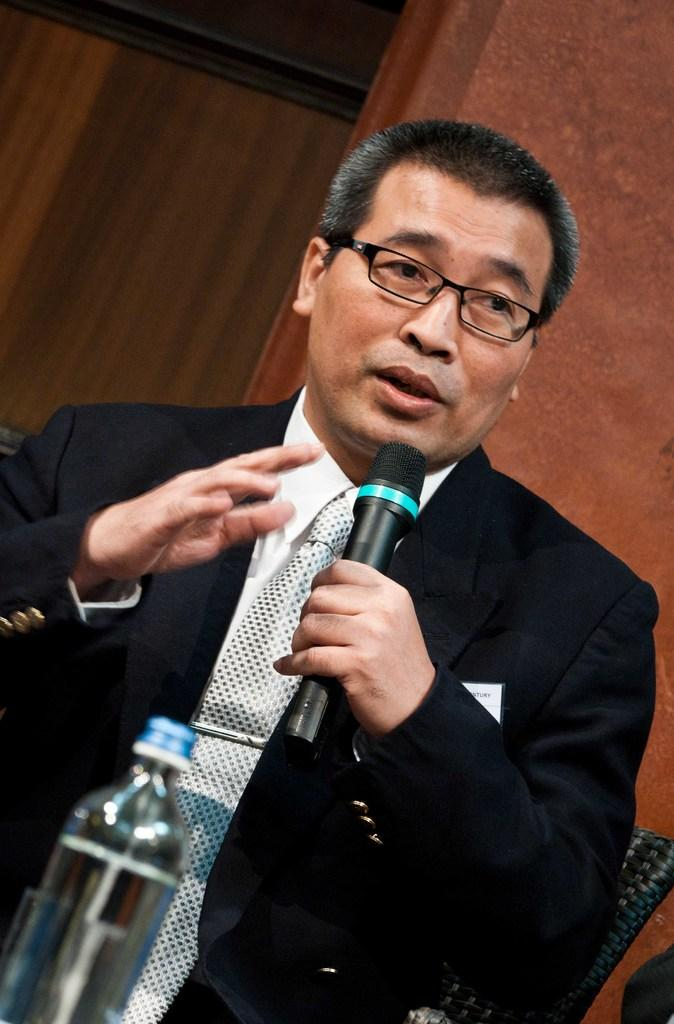What is the man in the image wearing? The man is wearing a black coat in the image. What is the man doing in the image? The man is talking in the image. What object is the man holding? The man is holding a microphone in the image. What can be seen on the table in the image? There is a water bottle on a table in the image. Can the man control the weather with his mind in the image? There is no indication in the image that the man has any ability to control the weather with his mind. 